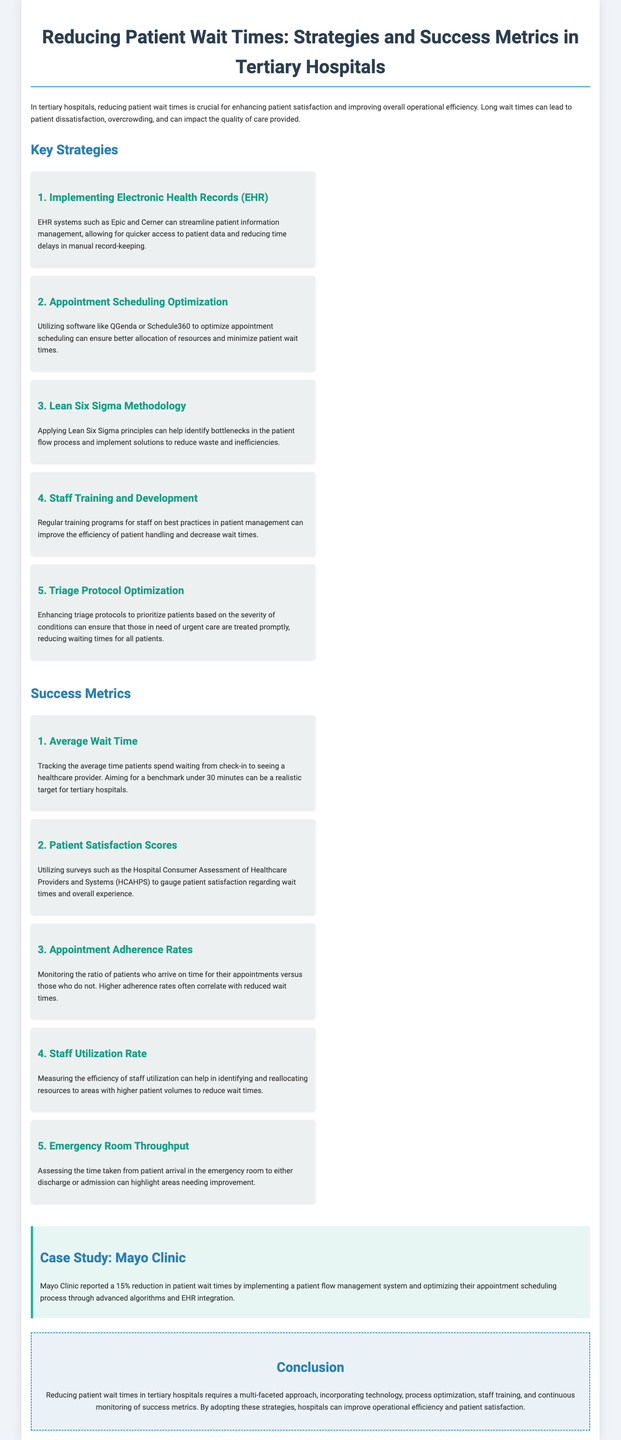what is the title of the document? The title of the document is presented prominently at the top as the main heading.
Answer: Reducing Patient Wait Times: Strategies and Success Metrics in Tertiary Hospitals what is one strategy for reducing patient wait times? There are several strategies listed, one of which highlights the implementation of technology.
Answer: Implementing Electronic Health Records (EHR) what is the average wait time targeted for tertiary hospitals? The document specifies a benchmark that hospitals aim for in terms of patient wait times.
Answer: under 30 minutes which case study is mentioned in the document? The document references a specific hospital as an example of implementing strategies.
Answer: Mayo Clinic what is one success metric associated with patient satisfaction? The document lists key metrics, one of which specifically deals with patient feedback.
Answer: Patient Satisfaction Scores what methodology is suggested for identifying bottlenecks in patient flow? The document mentions a specific set of principles designed to optimize processes.
Answer: Lean Six Sigma Methodology how much reduction in patient wait times did Mayo Clinic report? The case study provides a quantitative measure of success in their initiative.
Answer: 15% what primary focus do the outlined strategies emphasize? The document centers on enhancing certain operational aspects to improve patient management.
Answer: Operational efficiency what technology is recommended for appointment scheduling? A specific type of software is suggested to optimize scheduling in the healthcare setting.
Answer: QGenda or Schedule360 what appears at the end of the document summarizing key points? The document concludes with a reflection of overall findings and recommendations.
Answer: Conclusion 